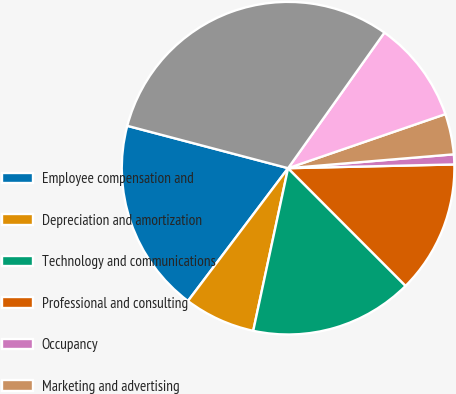Convert chart. <chart><loc_0><loc_0><loc_500><loc_500><pie_chart><fcel>Employee compensation and<fcel>Depreciation and amortization<fcel>Technology and communications<fcel>Professional and consulting<fcel>Occupancy<fcel>Marketing and advertising<fcel>General and administrative<fcel>Total expenses<nl><fcel>18.82%<fcel>6.92%<fcel>15.85%<fcel>12.87%<fcel>0.97%<fcel>3.94%<fcel>9.9%<fcel>30.73%<nl></chart> 